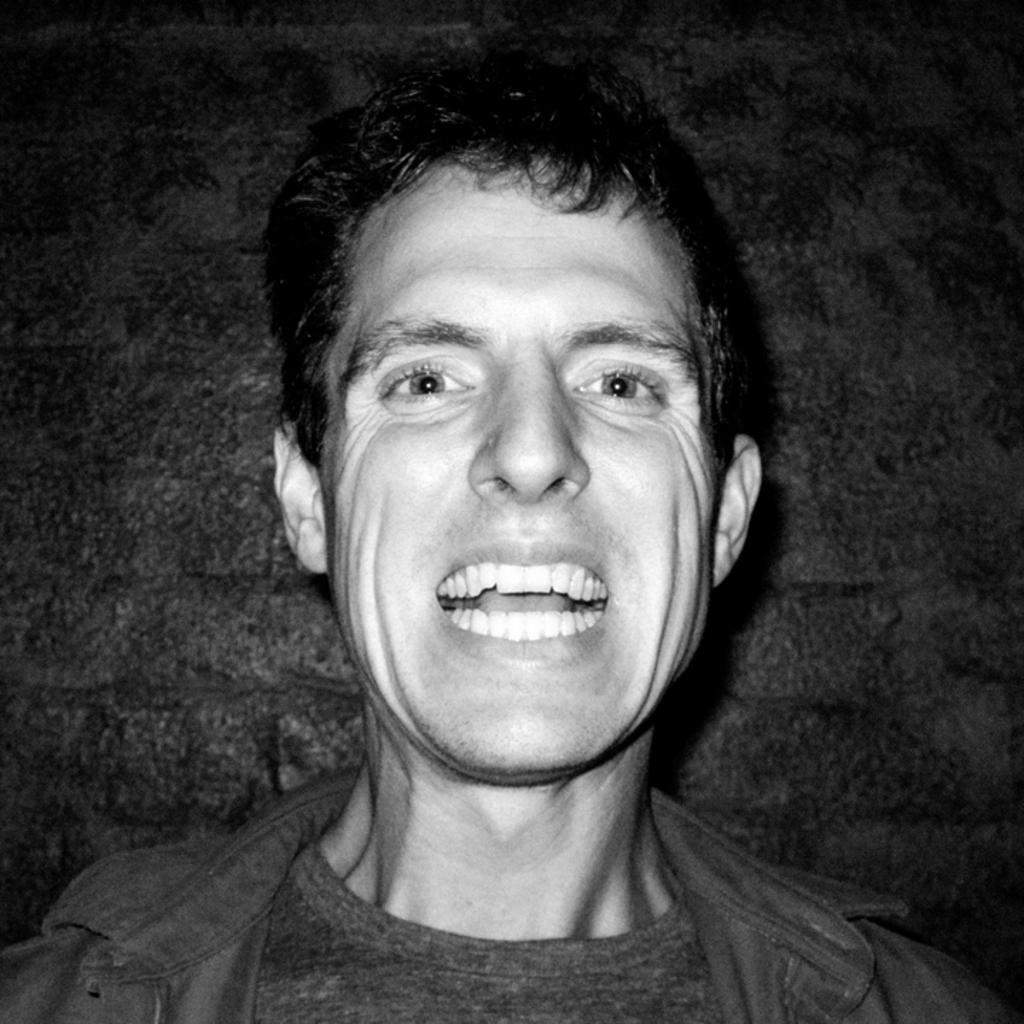In one or two sentences, can you explain what this image depicts? This is a black and white picture of a man smiling and behind him there is wall. 